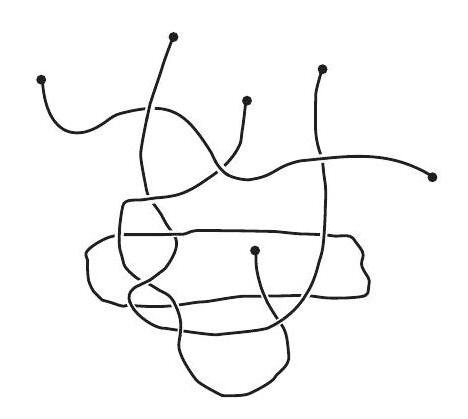How many pieces of string are there in the picture? There are 4 pieces of string in the picture, each looped and tangled in a complex interweaving pattern that creates an intricate and abstract design. 